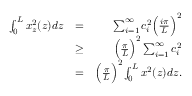Convert formula to latex. <formula><loc_0><loc_0><loc_500><loc_500>\begin{array} { r l r } { \int _ { 0 } ^ { L } x _ { z } ^ { 2 } ( z ) d z } & { = } & { \sum _ { i = 1 } ^ { \infty } c _ { i } ^ { 2 } \left ( \frac { i \pi } { L } \right ) ^ { 2 } } \\ & { \geq } & { \left ( \frac { \pi } { L } \right ) ^ { 2 } \sum _ { i = 1 } ^ { \infty } c _ { i } ^ { 2 } } \\ & { = } & { \left ( \frac { \pi } { L } \right ) ^ { 2 } \int _ { 0 } ^ { L } x ^ { 2 } ( z ) d z . } \end{array}</formula> 